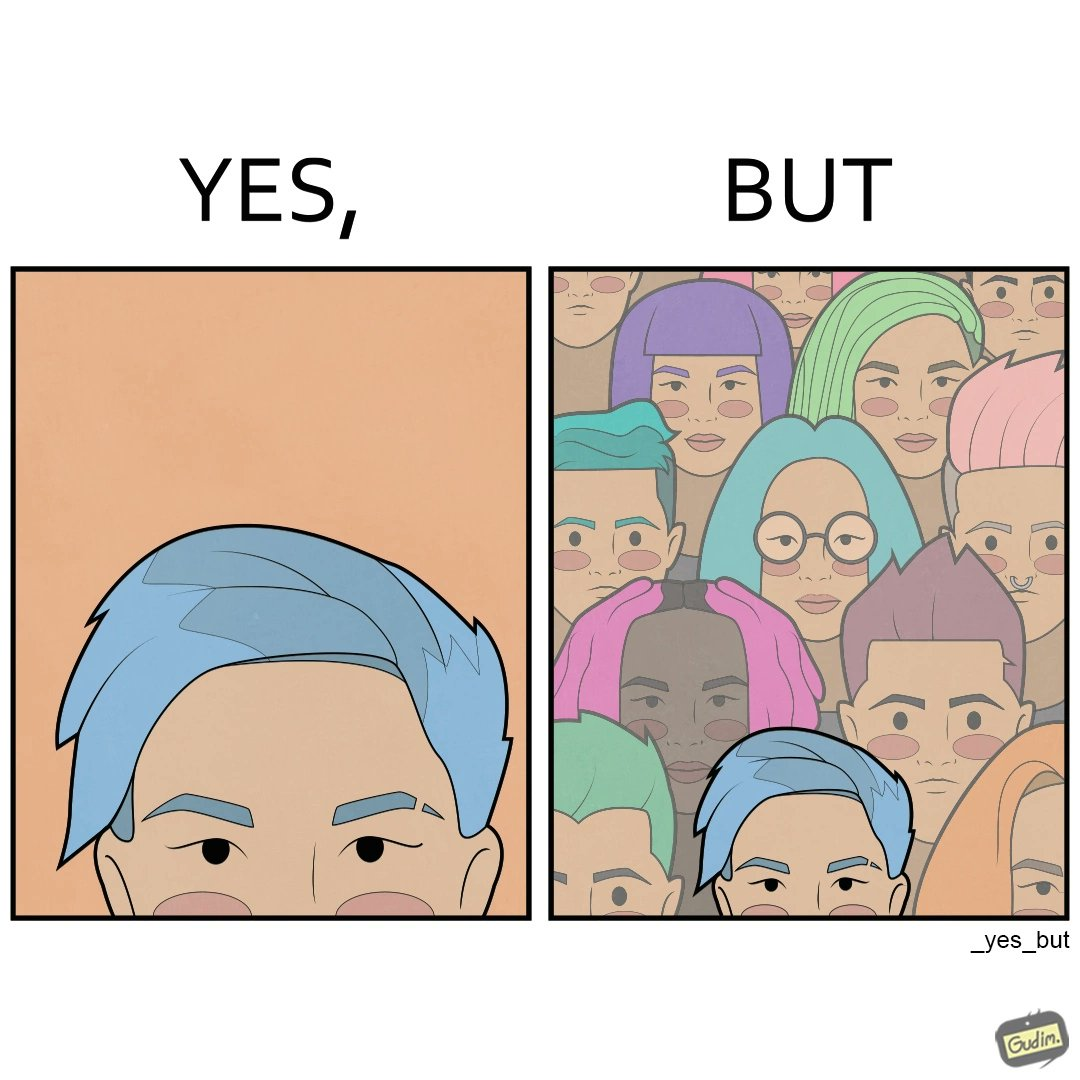What is the satirical meaning behind this image? The image is funny, as one person with a hair dyed blue seems to symbolize that the person is going against the grain, however, when we zoom out, the group of people have hair dyed in several, different colors, showing that, dyeing hair is the new normal. 